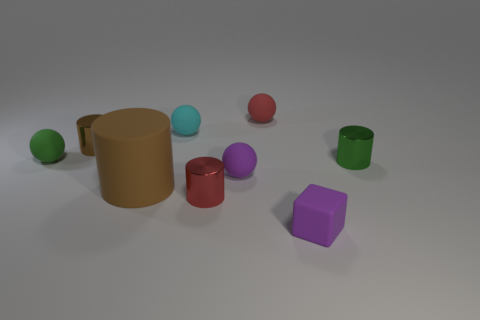What number of other things are there of the same size as the red ball?
Your response must be concise. 7. There is a cylinder that is both behind the large matte cylinder and to the left of the red metallic cylinder; how big is it?
Your response must be concise. Small. There is a matte cube; is it the same color as the small metal object that is to the right of the tiny purple rubber cube?
Keep it short and to the point. No. Are there any big purple things that have the same shape as the brown metal thing?
Provide a short and direct response. No. How many things are either large blue cubes or matte things that are behind the large brown cylinder?
Offer a very short reply. 4. How many other objects are there of the same material as the tiny red ball?
Your response must be concise. 5. How many objects are either purple things or tiny metallic objects?
Your answer should be compact. 5. Are there more small matte blocks that are behind the brown matte cylinder than matte objects left of the purple block?
Your response must be concise. No. Do the small metal cylinder that is on the left side of the cyan matte sphere and the tiny cylinder that is to the right of the purple matte ball have the same color?
Keep it short and to the point. No. There is a sphere left of the cyan rubber sphere that is right of the tiny cylinder on the left side of the red shiny object; what is its size?
Your response must be concise. Small. 